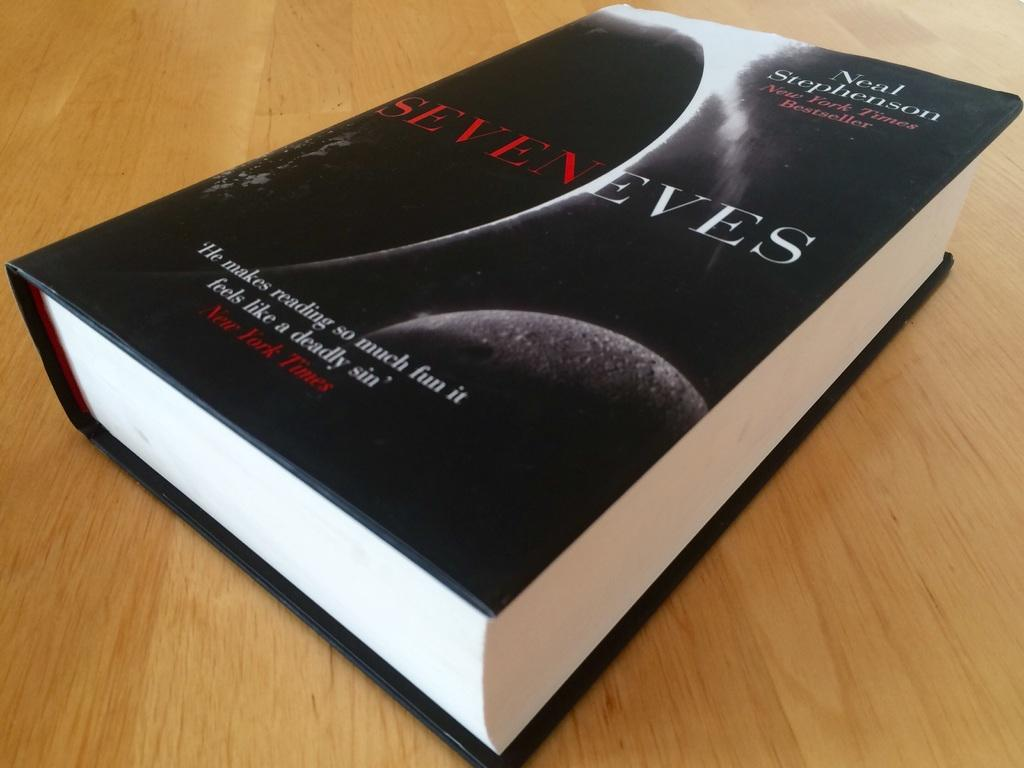<image>
Share a concise interpretation of the image provided. The book Seven Eves was written by Neal Stephenson. 